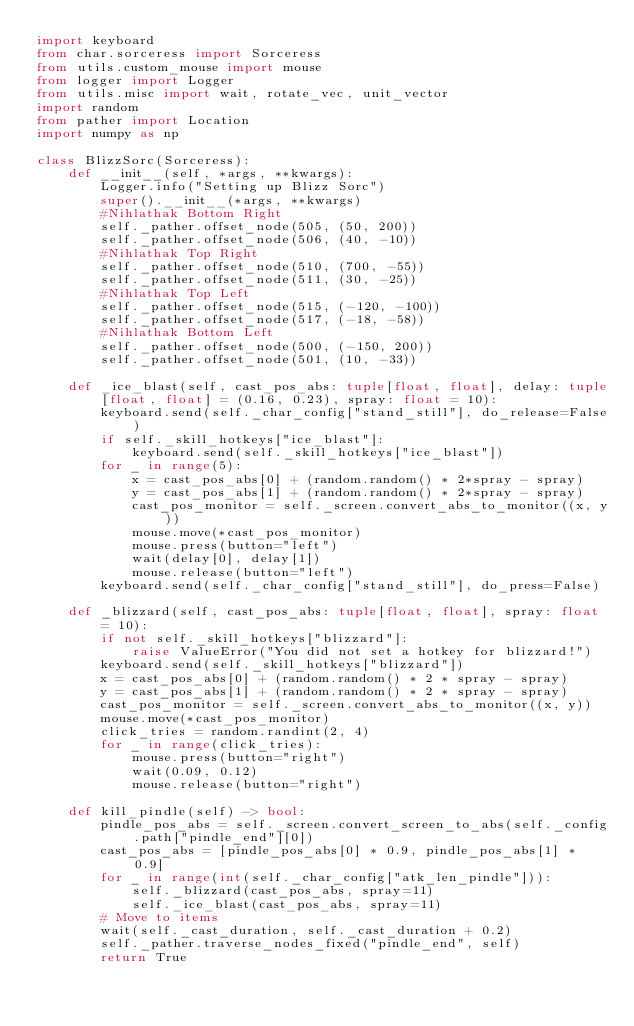Convert code to text. <code><loc_0><loc_0><loc_500><loc_500><_Python_>import keyboard
from char.sorceress import Sorceress
from utils.custom_mouse import mouse
from logger import Logger
from utils.misc import wait, rotate_vec, unit_vector
import random
from pather import Location
import numpy as np

class BlizzSorc(Sorceress):
    def __init__(self, *args, **kwargs):
        Logger.info("Setting up Blizz Sorc")
        super().__init__(*args, **kwargs)
        #Nihlathak Bottom Right
        self._pather.offset_node(505, (50, 200))
        self._pather.offset_node(506, (40, -10))
        #Nihlathak Top Right
        self._pather.offset_node(510, (700, -55))
        self._pather.offset_node(511, (30, -25))
        #Nihlathak Top Left
        self._pather.offset_node(515, (-120, -100))
        self._pather.offset_node(517, (-18, -58))
        #Nihlathak Bottom Left
        self._pather.offset_node(500, (-150, 200))
        self._pather.offset_node(501, (10, -33))

    def _ice_blast(self, cast_pos_abs: tuple[float, float], delay: tuple[float, float] = (0.16, 0.23), spray: float = 10):
        keyboard.send(self._char_config["stand_still"], do_release=False)
        if self._skill_hotkeys["ice_blast"]:
            keyboard.send(self._skill_hotkeys["ice_blast"])
        for _ in range(5):
            x = cast_pos_abs[0] + (random.random() * 2*spray - spray)
            y = cast_pos_abs[1] + (random.random() * 2*spray - spray)
            cast_pos_monitor = self._screen.convert_abs_to_monitor((x, y))
            mouse.move(*cast_pos_monitor)
            mouse.press(button="left")
            wait(delay[0], delay[1])
            mouse.release(button="left")
        keyboard.send(self._char_config["stand_still"], do_press=False)

    def _blizzard(self, cast_pos_abs: tuple[float, float], spray: float = 10):
        if not self._skill_hotkeys["blizzard"]:
            raise ValueError("You did not set a hotkey for blizzard!")
        keyboard.send(self._skill_hotkeys["blizzard"])
        x = cast_pos_abs[0] + (random.random() * 2 * spray - spray)
        y = cast_pos_abs[1] + (random.random() * 2 * spray - spray)
        cast_pos_monitor = self._screen.convert_abs_to_monitor((x, y))
        mouse.move(*cast_pos_monitor)
        click_tries = random.randint(2, 4)
        for _ in range(click_tries):
            mouse.press(button="right")
            wait(0.09, 0.12)
            mouse.release(button="right")

    def kill_pindle(self) -> bool:
        pindle_pos_abs = self._screen.convert_screen_to_abs(self._config.path["pindle_end"][0])
        cast_pos_abs = [pindle_pos_abs[0] * 0.9, pindle_pos_abs[1] * 0.9]
        for _ in range(int(self._char_config["atk_len_pindle"])):
            self._blizzard(cast_pos_abs, spray=11)
            self._ice_blast(cast_pos_abs, spray=11)
        # Move to items
        wait(self._cast_duration, self._cast_duration + 0.2)
        self._pather.traverse_nodes_fixed("pindle_end", self)
        return True
</code> 